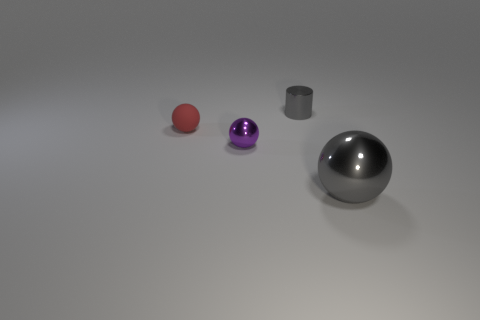There is a thing that is both right of the tiny purple object and behind the large gray object; what color is it?
Keep it short and to the point. Gray. Is the number of big balls that are in front of the small gray object less than the number of matte spheres on the left side of the red matte object?
Provide a succinct answer. No. How many small shiny objects have the same shape as the big gray thing?
Offer a terse response. 1. What is the size of the gray ball that is made of the same material as the purple sphere?
Provide a short and direct response. Large. What is the color of the tiny ball that is in front of the tiny rubber thing that is to the left of the purple ball?
Keep it short and to the point. Purple. There is a purple thing; does it have the same shape as the gray object that is behind the big gray ball?
Provide a succinct answer. No. What number of other metal things have the same size as the red thing?
Give a very brief answer. 2. There is another tiny object that is the same shape as the purple shiny thing; what material is it?
Your answer should be very brief. Rubber. There is a metal thing that is on the left side of the gray cylinder; is its color the same as the sphere behind the purple metallic thing?
Offer a terse response. No. There is a gray metal thing on the left side of the gray metal ball; what shape is it?
Your response must be concise. Cylinder. 